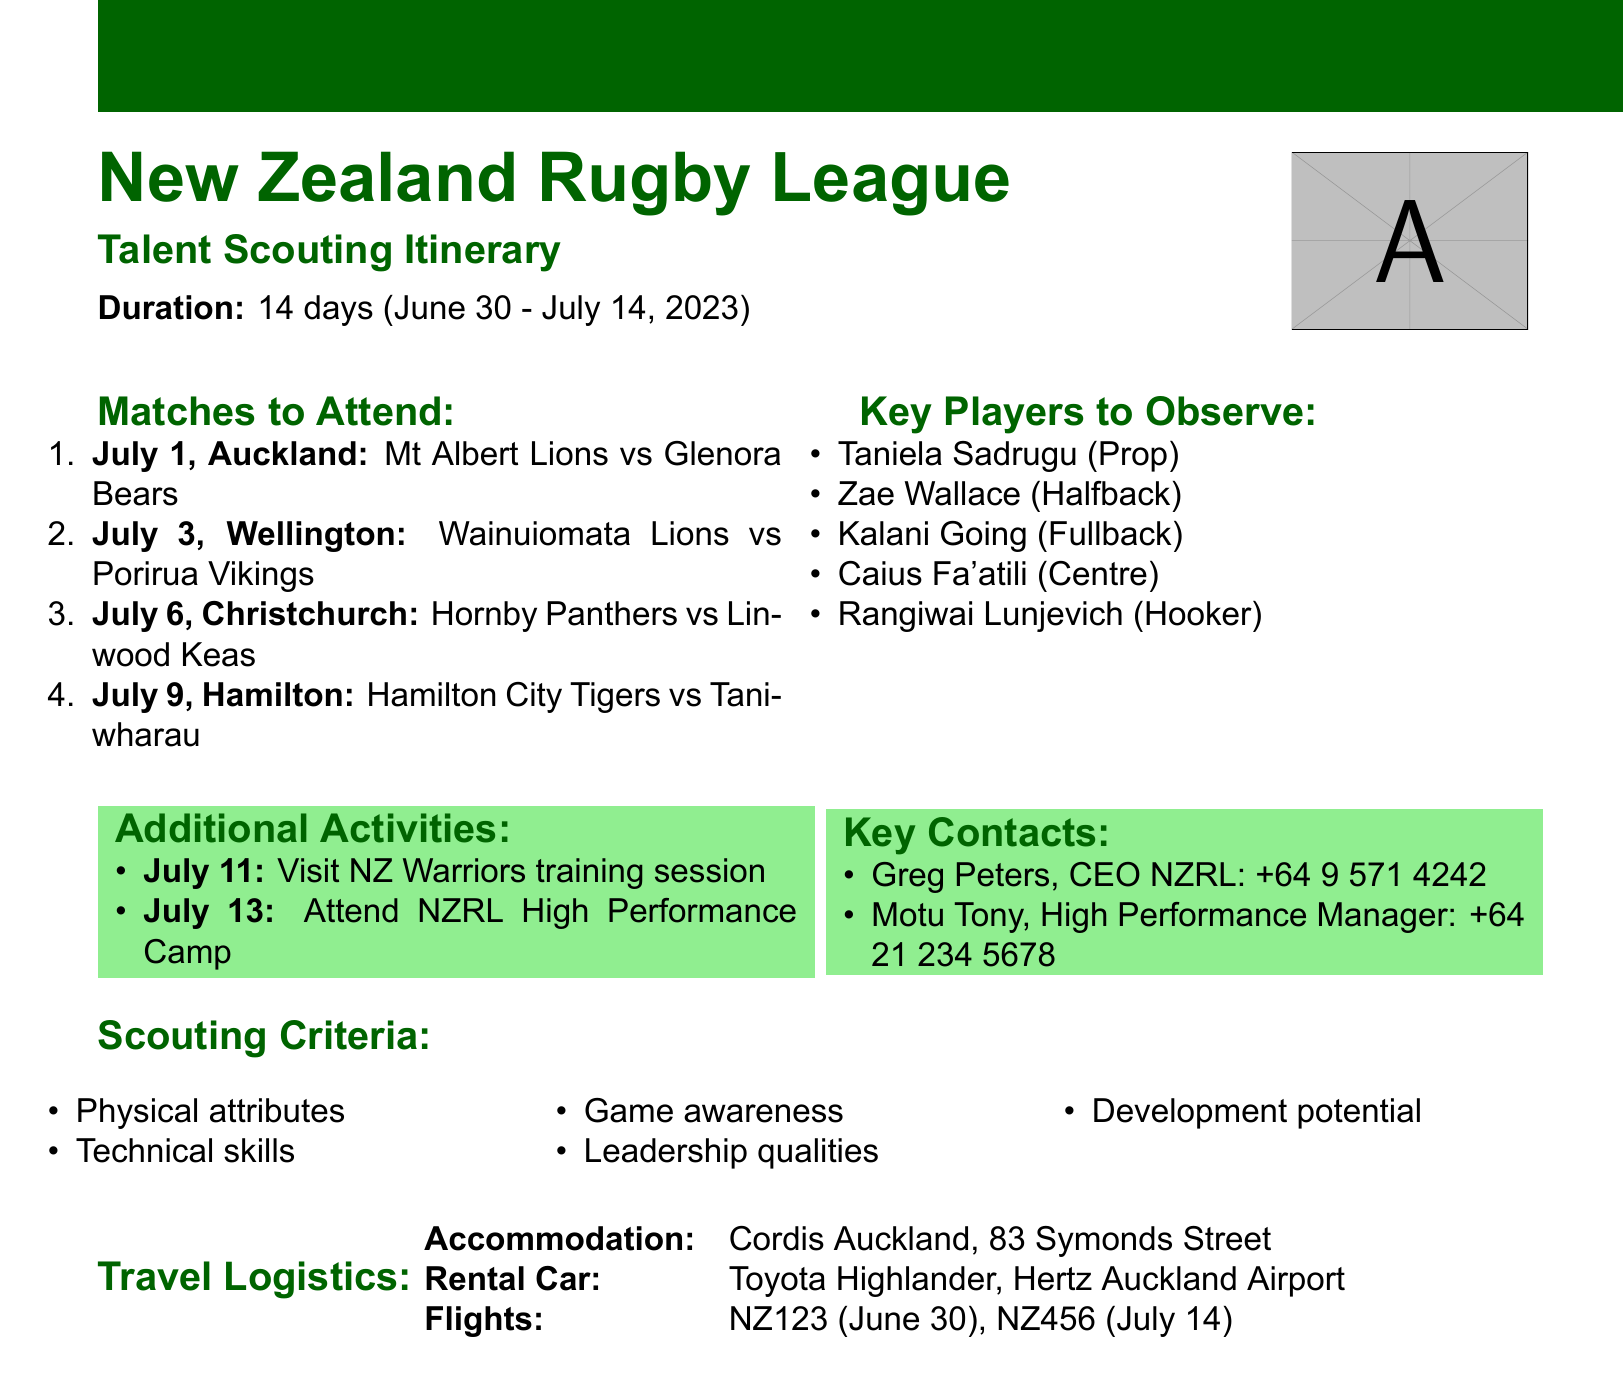What is the trip duration? The trip duration is specified in the document as a total of 14 days.
Answer: 14 days What is the primary objective of the trip? The primary objective is mentioned clearly in the document as scouting talented rugby league players for potential recruitment.
Answer: Scout talented rugby league players for potential recruitment Which team will the scouts observe in Christchurch? The document lists the matches to attend, including the one occurring in Christchurch featuring Hornby Panthers vs Linwood Keas.
Answer: Hornby Panthers vs Linwood Keas Who is the contact for the NZ Warriors training session? A specific contact for the NZ Warriors training session is provided, which is Cameron George.
Answer: Cameron George What are the players to observe in Wellington? The document provides a list of players to observe in the Wellington match, including Kalani Going and others.
Answer: Kalani Going, Tyrone Ngataki, Alex Leapai Jr What is the address of the accommodation? The document specifies that the accommodation is at Cordis Auckland, located at 83 Symonds Street.
Answer: Cordis Auckland, 83 Symonds Street Which flight departs on July 14? The flight information includes flight numbers and dates, indicating that NZ456 is the flight departing on July 14.
Answer: NZ456 What are the scouting criteria listed in the document? The document outlines the scouting criteria, which includes aspects such as physical attributes and technical skills.
Answer: Physical attributes, Technical skills, Game awareness, Leadership qualities, Development potential What additional activity is scheduled for July 11? An additional activity listed in the document is visiting the NZ Warriors training session, which is noted for July 11.
Answer: Visit NZ Warriors training session 